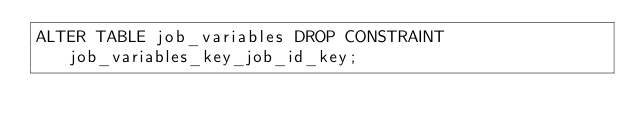Convert code to text. <code><loc_0><loc_0><loc_500><loc_500><_SQL_>ALTER TABLE job_variables DROP CONSTRAINT job_variables_key_job_id_key;
</code> 